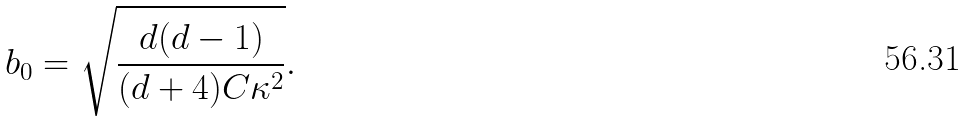<formula> <loc_0><loc_0><loc_500><loc_500>b _ { 0 } = \sqrt { \frac { d ( d - 1 ) } { ( d + 4 ) C \kappa ^ { 2 } } } .</formula> 